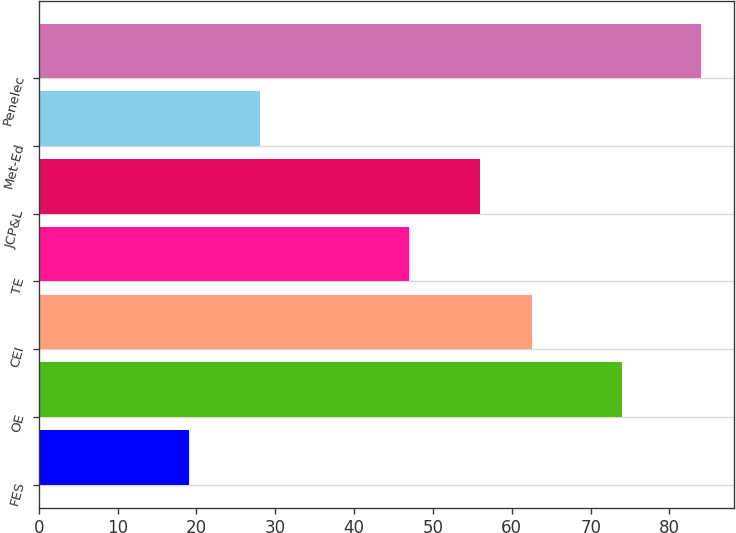Convert chart. <chart><loc_0><loc_0><loc_500><loc_500><bar_chart><fcel>FES<fcel>OE<fcel>CEI<fcel>TE<fcel>JCP&L<fcel>Met-Ed<fcel>Penelec<nl><fcel>19<fcel>74<fcel>62.5<fcel>47<fcel>56<fcel>28<fcel>84<nl></chart> 